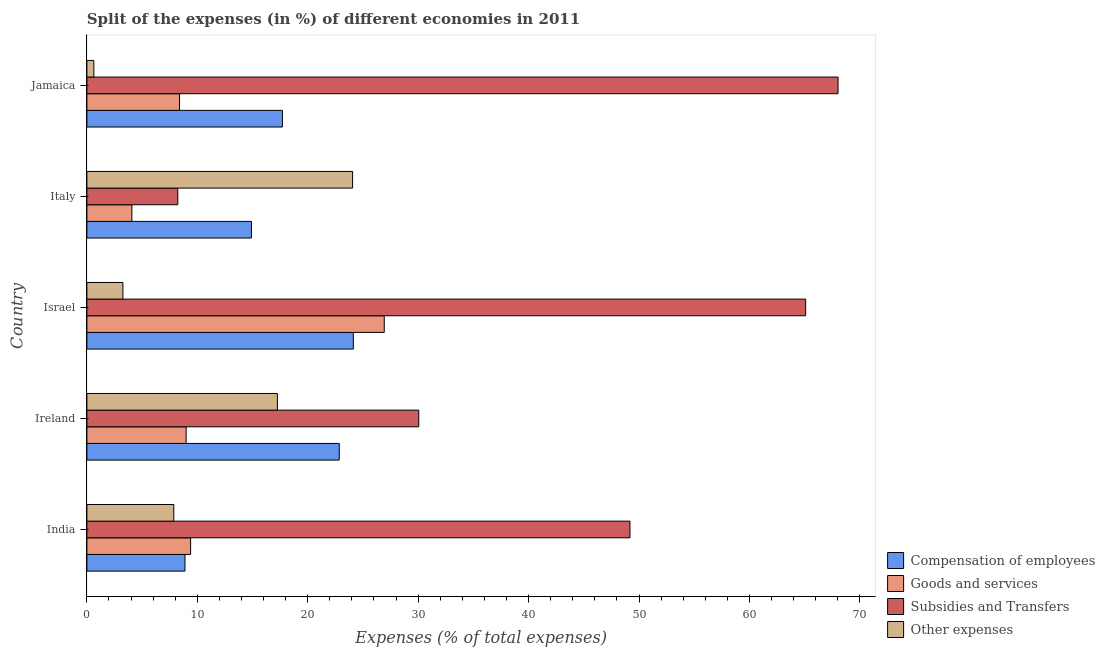How many different coloured bars are there?
Your answer should be compact. 4. How many groups of bars are there?
Offer a terse response. 5. How many bars are there on the 3rd tick from the top?
Offer a very short reply. 4. How many bars are there on the 1st tick from the bottom?
Ensure brevity in your answer.  4. What is the label of the 4th group of bars from the top?
Your answer should be very brief. Ireland. What is the percentage of amount spent on subsidies in Israel?
Keep it short and to the point. 65.09. Across all countries, what is the maximum percentage of amount spent on goods and services?
Your answer should be compact. 26.93. Across all countries, what is the minimum percentage of amount spent on other expenses?
Keep it short and to the point. 0.63. What is the total percentage of amount spent on goods and services in the graph?
Make the answer very short. 57.77. What is the difference between the percentage of amount spent on compensation of employees in Ireland and that in Italy?
Your response must be concise. 7.95. What is the difference between the percentage of amount spent on other expenses in Jamaica and the percentage of amount spent on goods and services in Italy?
Make the answer very short. -3.44. What is the average percentage of amount spent on goods and services per country?
Provide a short and direct response. 11.55. What is the difference between the percentage of amount spent on compensation of employees and percentage of amount spent on other expenses in Israel?
Provide a short and direct response. 20.87. What is the ratio of the percentage of amount spent on compensation of employees in Ireland to that in Israel?
Ensure brevity in your answer.  0.95. Is the percentage of amount spent on subsidies in Ireland less than that in Italy?
Your answer should be compact. No. Is the difference between the percentage of amount spent on compensation of employees in Ireland and Israel greater than the difference between the percentage of amount spent on other expenses in Ireland and Israel?
Give a very brief answer. No. What is the difference between the highest and the second highest percentage of amount spent on subsidies?
Provide a succinct answer. 2.94. What is the difference between the highest and the lowest percentage of amount spent on subsidies?
Your response must be concise. 59.79. Is it the case that in every country, the sum of the percentage of amount spent on goods and services and percentage of amount spent on compensation of employees is greater than the sum of percentage of amount spent on subsidies and percentage of amount spent on other expenses?
Offer a very short reply. No. What does the 3rd bar from the top in India represents?
Your answer should be compact. Goods and services. What does the 1st bar from the bottom in Israel represents?
Your response must be concise. Compensation of employees. Is it the case that in every country, the sum of the percentage of amount spent on compensation of employees and percentage of amount spent on goods and services is greater than the percentage of amount spent on subsidies?
Ensure brevity in your answer.  No. Are all the bars in the graph horizontal?
Keep it short and to the point. Yes. How many countries are there in the graph?
Ensure brevity in your answer.  5. Does the graph contain any zero values?
Keep it short and to the point. No. Does the graph contain grids?
Make the answer very short. No. Where does the legend appear in the graph?
Provide a short and direct response. Bottom right. How many legend labels are there?
Provide a short and direct response. 4. What is the title of the graph?
Your response must be concise. Split of the expenses (in %) of different economies in 2011. Does "Other expenses" appear as one of the legend labels in the graph?
Your answer should be very brief. Yes. What is the label or title of the X-axis?
Provide a short and direct response. Expenses (% of total expenses). What is the Expenses (% of total expenses) in Compensation of employees in India?
Provide a short and direct response. 8.88. What is the Expenses (% of total expenses) in Goods and services in India?
Provide a short and direct response. 9.39. What is the Expenses (% of total expenses) in Subsidies and Transfers in India?
Keep it short and to the point. 49.18. What is the Expenses (% of total expenses) of Other expenses in India?
Offer a terse response. 7.87. What is the Expenses (% of total expenses) in Compensation of employees in Ireland?
Give a very brief answer. 22.86. What is the Expenses (% of total expenses) of Goods and services in Ireland?
Provide a short and direct response. 8.99. What is the Expenses (% of total expenses) of Subsidies and Transfers in Ireland?
Provide a succinct answer. 30.06. What is the Expenses (% of total expenses) in Other expenses in Ireland?
Keep it short and to the point. 17.25. What is the Expenses (% of total expenses) of Compensation of employees in Israel?
Your answer should be compact. 24.13. What is the Expenses (% of total expenses) of Goods and services in Israel?
Your answer should be compact. 26.93. What is the Expenses (% of total expenses) of Subsidies and Transfers in Israel?
Give a very brief answer. 65.09. What is the Expenses (% of total expenses) in Other expenses in Israel?
Make the answer very short. 3.26. What is the Expenses (% of total expenses) in Compensation of employees in Italy?
Ensure brevity in your answer.  14.9. What is the Expenses (% of total expenses) of Goods and services in Italy?
Your answer should be compact. 4.07. What is the Expenses (% of total expenses) of Subsidies and Transfers in Italy?
Provide a succinct answer. 8.23. What is the Expenses (% of total expenses) in Other expenses in Italy?
Provide a short and direct response. 24.06. What is the Expenses (% of total expenses) of Compensation of employees in Jamaica?
Offer a terse response. 17.71. What is the Expenses (% of total expenses) in Goods and services in Jamaica?
Give a very brief answer. 8.39. What is the Expenses (% of total expenses) of Subsidies and Transfers in Jamaica?
Your answer should be compact. 68.03. What is the Expenses (% of total expenses) in Other expenses in Jamaica?
Provide a succinct answer. 0.63. Across all countries, what is the maximum Expenses (% of total expenses) in Compensation of employees?
Offer a terse response. 24.13. Across all countries, what is the maximum Expenses (% of total expenses) in Goods and services?
Make the answer very short. 26.93. Across all countries, what is the maximum Expenses (% of total expenses) in Subsidies and Transfers?
Keep it short and to the point. 68.03. Across all countries, what is the maximum Expenses (% of total expenses) of Other expenses?
Your response must be concise. 24.06. Across all countries, what is the minimum Expenses (% of total expenses) of Compensation of employees?
Your answer should be compact. 8.88. Across all countries, what is the minimum Expenses (% of total expenses) in Goods and services?
Your response must be concise. 4.07. Across all countries, what is the minimum Expenses (% of total expenses) of Subsidies and Transfers?
Your answer should be compact. 8.23. Across all countries, what is the minimum Expenses (% of total expenses) of Other expenses?
Offer a terse response. 0.63. What is the total Expenses (% of total expenses) in Compensation of employees in the graph?
Keep it short and to the point. 88.48. What is the total Expenses (% of total expenses) in Goods and services in the graph?
Provide a short and direct response. 57.77. What is the total Expenses (% of total expenses) of Subsidies and Transfers in the graph?
Ensure brevity in your answer.  220.59. What is the total Expenses (% of total expenses) in Other expenses in the graph?
Offer a terse response. 53.08. What is the difference between the Expenses (% of total expenses) of Compensation of employees in India and that in Ireland?
Keep it short and to the point. -13.97. What is the difference between the Expenses (% of total expenses) of Goods and services in India and that in Ireland?
Provide a short and direct response. 0.41. What is the difference between the Expenses (% of total expenses) of Subsidies and Transfers in India and that in Ireland?
Keep it short and to the point. 19.13. What is the difference between the Expenses (% of total expenses) in Other expenses in India and that in Ireland?
Your answer should be compact. -9.38. What is the difference between the Expenses (% of total expenses) in Compensation of employees in India and that in Israel?
Your response must be concise. -15.25. What is the difference between the Expenses (% of total expenses) in Goods and services in India and that in Israel?
Offer a terse response. -17.54. What is the difference between the Expenses (% of total expenses) of Subsidies and Transfers in India and that in Israel?
Make the answer very short. -15.91. What is the difference between the Expenses (% of total expenses) in Other expenses in India and that in Israel?
Give a very brief answer. 4.61. What is the difference between the Expenses (% of total expenses) in Compensation of employees in India and that in Italy?
Your answer should be very brief. -6.02. What is the difference between the Expenses (% of total expenses) of Goods and services in India and that in Italy?
Your response must be concise. 5.32. What is the difference between the Expenses (% of total expenses) of Subsidies and Transfers in India and that in Italy?
Make the answer very short. 40.95. What is the difference between the Expenses (% of total expenses) of Other expenses in India and that in Italy?
Your answer should be compact. -16.19. What is the difference between the Expenses (% of total expenses) of Compensation of employees in India and that in Jamaica?
Make the answer very short. -8.83. What is the difference between the Expenses (% of total expenses) of Subsidies and Transfers in India and that in Jamaica?
Give a very brief answer. -18.84. What is the difference between the Expenses (% of total expenses) in Other expenses in India and that in Jamaica?
Give a very brief answer. 7.24. What is the difference between the Expenses (% of total expenses) in Compensation of employees in Ireland and that in Israel?
Your answer should be compact. -1.28. What is the difference between the Expenses (% of total expenses) in Goods and services in Ireland and that in Israel?
Provide a succinct answer. -17.94. What is the difference between the Expenses (% of total expenses) in Subsidies and Transfers in Ireland and that in Israel?
Provide a succinct answer. -35.03. What is the difference between the Expenses (% of total expenses) of Other expenses in Ireland and that in Israel?
Give a very brief answer. 13.99. What is the difference between the Expenses (% of total expenses) of Compensation of employees in Ireland and that in Italy?
Make the answer very short. 7.95. What is the difference between the Expenses (% of total expenses) in Goods and services in Ireland and that in Italy?
Your response must be concise. 4.91. What is the difference between the Expenses (% of total expenses) of Subsidies and Transfers in Ireland and that in Italy?
Provide a short and direct response. 21.82. What is the difference between the Expenses (% of total expenses) of Other expenses in Ireland and that in Italy?
Ensure brevity in your answer.  -6.81. What is the difference between the Expenses (% of total expenses) of Compensation of employees in Ireland and that in Jamaica?
Make the answer very short. 5.15. What is the difference between the Expenses (% of total expenses) in Goods and services in Ireland and that in Jamaica?
Ensure brevity in your answer.  0.6. What is the difference between the Expenses (% of total expenses) of Subsidies and Transfers in Ireland and that in Jamaica?
Provide a short and direct response. -37.97. What is the difference between the Expenses (% of total expenses) of Other expenses in Ireland and that in Jamaica?
Give a very brief answer. 16.62. What is the difference between the Expenses (% of total expenses) in Compensation of employees in Israel and that in Italy?
Give a very brief answer. 9.23. What is the difference between the Expenses (% of total expenses) in Goods and services in Israel and that in Italy?
Make the answer very short. 22.86. What is the difference between the Expenses (% of total expenses) of Subsidies and Transfers in Israel and that in Italy?
Give a very brief answer. 56.86. What is the difference between the Expenses (% of total expenses) of Other expenses in Israel and that in Italy?
Provide a short and direct response. -20.8. What is the difference between the Expenses (% of total expenses) in Compensation of employees in Israel and that in Jamaica?
Make the answer very short. 6.42. What is the difference between the Expenses (% of total expenses) in Goods and services in Israel and that in Jamaica?
Keep it short and to the point. 18.54. What is the difference between the Expenses (% of total expenses) of Subsidies and Transfers in Israel and that in Jamaica?
Give a very brief answer. -2.94. What is the difference between the Expenses (% of total expenses) of Other expenses in Israel and that in Jamaica?
Your answer should be compact. 2.63. What is the difference between the Expenses (% of total expenses) in Compensation of employees in Italy and that in Jamaica?
Provide a succinct answer. -2.8. What is the difference between the Expenses (% of total expenses) in Goods and services in Italy and that in Jamaica?
Ensure brevity in your answer.  -4.32. What is the difference between the Expenses (% of total expenses) in Subsidies and Transfers in Italy and that in Jamaica?
Offer a terse response. -59.79. What is the difference between the Expenses (% of total expenses) of Other expenses in Italy and that in Jamaica?
Give a very brief answer. 23.43. What is the difference between the Expenses (% of total expenses) of Compensation of employees in India and the Expenses (% of total expenses) of Goods and services in Ireland?
Your answer should be very brief. -0.11. What is the difference between the Expenses (% of total expenses) in Compensation of employees in India and the Expenses (% of total expenses) in Subsidies and Transfers in Ireland?
Ensure brevity in your answer.  -21.17. What is the difference between the Expenses (% of total expenses) in Compensation of employees in India and the Expenses (% of total expenses) in Other expenses in Ireland?
Offer a very short reply. -8.37. What is the difference between the Expenses (% of total expenses) in Goods and services in India and the Expenses (% of total expenses) in Subsidies and Transfers in Ireland?
Your response must be concise. -20.66. What is the difference between the Expenses (% of total expenses) of Goods and services in India and the Expenses (% of total expenses) of Other expenses in Ireland?
Make the answer very short. -7.86. What is the difference between the Expenses (% of total expenses) in Subsidies and Transfers in India and the Expenses (% of total expenses) in Other expenses in Ireland?
Provide a short and direct response. 31.93. What is the difference between the Expenses (% of total expenses) in Compensation of employees in India and the Expenses (% of total expenses) in Goods and services in Israel?
Provide a short and direct response. -18.05. What is the difference between the Expenses (% of total expenses) in Compensation of employees in India and the Expenses (% of total expenses) in Subsidies and Transfers in Israel?
Offer a very short reply. -56.21. What is the difference between the Expenses (% of total expenses) in Compensation of employees in India and the Expenses (% of total expenses) in Other expenses in Israel?
Give a very brief answer. 5.62. What is the difference between the Expenses (% of total expenses) of Goods and services in India and the Expenses (% of total expenses) of Subsidies and Transfers in Israel?
Provide a succinct answer. -55.7. What is the difference between the Expenses (% of total expenses) in Goods and services in India and the Expenses (% of total expenses) in Other expenses in Israel?
Make the answer very short. 6.13. What is the difference between the Expenses (% of total expenses) of Subsidies and Transfers in India and the Expenses (% of total expenses) of Other expenses in Israel?
Offer a very short reply. 45.92. What is the difference between the Expenses (% of total expenses) in Compensation of employees in India and the Expenses (% of total expenses) in Goods and services in Italy?
Your response must be concise. 4.81. What is the difference between the Expenses (% of total expenses) of Compensation of employees in India and the Expenses (% of total expenses) of Subsidies and Transfers in Italy?
Keep it short and to the point. 0.65. What is the difference between the Expenses (% of total expenses) in Compensation of employees in India and the Expenses (% of total expenses) in Other expenses in Italy?
Offer a terse response. -15.18. What is the difference between the Expenses (% of total expenses) of Goods and services in India and the Expenses (% of total expenses) of Subsidies and Transfers in Italy?
Make the answer very short. 1.16. What is the difference between the Expenses (% of total expenses) in Goods and services in India and the Expenses (% of total expenses) in Other expenses in Italy?
Provide a succinct answer. -14.67. What is the difference between the Expenses (% of total expenses) of Subsidies and Transfers in India and the Expenses (% of total expenses) of Other expenses in Italy?
Keep it short and to the point. 25.12. What is the difference between the Expenses (% of total expenses) of Compensation of employees in India and the Expenses (% of total expenses) of Goods and services in Jamaica?
Offer a terse response. 0.49. What is the difference between the Expenses (% of total expenses) in Compensation of employees in India and the Expenses (% of total expenses) in Subsidies and Transfers in Jamaica?
Your answer should be compact. -59.15. What is the difference between the Expenses (% of total expenses) of Compensation of employees in India and the Expenses (% of total expenses) of Other expenses in Jamaica?
Ensure brevity in your answer.  8.25. What is the difference between the Expenses (% of total expenses) in Goods and services in India and the Expenses (% of total expenses) in Subsidies and Transfers in Jamaica?
Keep it short and to the point. -58.63. What is the difference between the Expenses (% of total expenses) in Goods and services in India and the Expenses (% of total expenses) in Other expenses in Jamaica?
Ensure brevity in your answer.  8.76. What is the difference between the Expenses (% of total expenses) of Subsidies and Transfers in India and the Expenses (% of total expenses) of Other expenses in Jamaica?
Give a very brief answer. 48.55. What is the difference between the Expenses (% of total expenses) of Compensation of employees in Ireland and the Expenses (% of total expenses) of Goods and services in Israel?
Give a very brief answer. -4.07. What is the difference between the Expenses (% of total expenses) in Compensation of employees in Ireland and the Expenses (% of total expenses) in Subsidies and Transfers in Israel?
Provide a succinct answer. -42.23. What is the difference between the Expenses (% of total expenses) of Compensation of employees in Ireland and the Expenses (% of total expenses) of Other expenses in Israel?
Ensure brevity in your answer.  19.59. What is the difference between the Expenses (% of total expenses) in Goods and services in Ireland and the Expenses (% of total expenses) in Subsidies and Transfers in Israel?
Offer a very short reply. -56.1. What is the difference between the Expenses (% of total expenses) of Goods and services in Ireland and the Expenses (% of total expenses) of Other expenses in Israel?
Your answer should be compact. 5.73. What is the difference between the Expenses (% of total expenses) in Subsidies and Transfers in Ireland and the Expenses (% of total expenses) in Other expenses in Israel?
Offer a terse response. 26.79. What is the difference between the Expenses (% of total expenses) of Compensation of employees in Ireland and the Expenses (% of total expenses) of Goods and services in Italy?
Offer a very short reply. 18.78. What is the difference between the Expenses (% of total expenses) in Compensation of employees in Ireland and the Expenses (% of total expenses) in Subsidies and Transfers in Italy?
Offer a very short reply. 14.62. What is the difference between the Expenses (% of total expenses) of Compensation of employees in Ireland and the Expenses (% of total expenses) of Other expenses in Italy?
Provide a short and direct response. -1.21. What is the difference between the Expenses (% of total expenses) in Goods and services in Ireland and the Expenses (% of total expenses) in Subsidies and Transfers in Italy?
Your answer should be compact. 0.75. What is the difference between the Expenses (% of total expenses) of Goods and services in Ireland and the Expenses (% of total expenses) of Other expenses in Italy?
Offer a terse response. -15.08. What is the difference between the Expenses (% of total expenses) of Subsidies and Transfers in Ireland and the Expenses (% of total expenses) of Other expenses in Italy?
Make the answer very short. 5.99. What is the difference between the Expenses (% of total expenses) in Compensation of employees in Ireland and the Expenses (% of total expenses) in Goods and services in Jamaica?
Ensure brevity in your answer.  14.47. What is the difference between the Expenses (% of total expenses) of Compensation of employees in Ireland and the Expenses (% of total expenses) of Subsidies and Transfers in Jamaica?
Offer a very short reply. -45.17. What is the difference between the Expenses (% of total expenses) of Compensation of employees in Ireland and the Expenses (% of total expenses) of Other expenses in Jamaica?
Offer a very short reply. 22.22. What is the difference between the Expenses (% of total expenses) of Goods and services in Ireland and the Expenses (% of total expenses) of Subsidies and Transfers in Jamaica?
Your answer should be compact. -59.04. What is the difference between the Expenses (% of total expenses) in Goods and services in Ireland and the Expenses (% of total expenses) in Other expenses in Jamaica?
Make the answer very short. 8.35. What is the difference between the Expenses (% of total expenses) of Subsidies and Transfers in Ireland and the Expenses (% of total expenses) of Other expenses in Jamaica?
Offer a very short reply. 29.42. What is the difference between the Expenses (% of total expenses) of Compensation of employees in Israel and the Expenses (% of total expenses) of Goods and services in Italy?
Give a very brief answer. 20.06. What is the difference between the Expenses (% of total expenses) of Compensation of employees in Israel and the Expenses (% of total expenses) of Subsidies and Transfers in Italy?
Offer a terse response. 15.9. What is the difference between the Expenses (% of total expenses) of Compensation of employees in Israel and the Expenses (% of total expenses) of Other expenses in Italy?
Your answer should be compact. 0.07. What is the difference between the Expenses (% of total expenses) of Goods and services in Israel and the Expenses (% of total expenses) of Subsidies and Transfers in Italy?
Give a very brief answer. 18.7. What is the difference between the Expenses (% of total expenses) in Goods and services in Israel and the Expenses (% of total expenses) in Other expenses in Italy?
Give a very brief answer. 2.87. What is the difference between the Expenses (% of total expenses) of Subsidies and Transfers in Israel and the Expenses (% of total expenses) of Other expenses in Italy?
Keep it short and to the point. 41.03. What is the difference between the Expenses (% of total expenses) in Compensation of employees in Israel and the Expenses (% of total expenses) in Goods and services in Jamaica?
Ensure brevity in your answer.  15.74. What is the difference between the Expenses (% of total expenses) of Compensation of employees in Israel and the Expenses (% of total expenses) of Subsidies and Transfers in Jamaica?
Your answer should be compact. -43.9. What is the difference between the Expenses (% of total expenses) in Compensation of employees in Israel and the Expenses (% of total expenses) in Other expenses in Jamaica?
Your answer should be very brief. 23.5. What is the difference between the Expenses (% of total expenses) of Goods and services in Israel and the Expenses (% of total expenses) of Subsidies and Transfers in Jamaica?
Your answer should be compact. -41.1. What is the difference between the Expenses (% of total expenses) of Goods and services in Israel and the Expenses (% of total expenses) of Other expenses in Jamaica?
Keep it short and to the point. 26.3. What is the difference between the Expenses (% of total expenses) in Subsidies and Transfers in Israel and the Expenses (% of total expenses) in Other expenses in Jamaica?
Your answer should be compact. 64.46. What is the difference between the Expenses (% of total expenses) of Compensation of employees in Italy and the Expenses (% of total expenses) of Goods and services in Jamaica?
Keep it short and to the point. 6.52. What is the difference between the Expenses (% of total expenses) of Compensation of employees in Italy and the Expenses (% of total expenses) of Subsidies and Transfers in Jamaica?
Make the answer very short. -53.12. What is the difference between the Expenses (% of total expenses) of Compensation of employees in Italy and the Expenses (% of total expenses) of Other expenses in Jamaica?
Keep it short and to the point. 14.27. What is the difference between the Expenses (% of total expenses) in Goods and services in Italy and the Expenses (% of total expenses) in Subsidies and Transfers in Jamaica?
Give a very brief answer. -63.95. What is the difference between the Expenses (% of total expenses) of Goods and services in Italy and the Expenses (% of total expenses) of Other expenses in Jamaica?
Ensure brevity in your answer.  3.44. What is the difference between the Expenses (% of total expenses) of Subsidies and Transfers in Italy and the Expenses (% of total expenses) of Other expenses in Jamaica?
Offer a very short reply. 7.6. What is the average Expenses (% of total expenses) in Compensation of employees per country?
Give a very brief answer. 17.7. What is the average Expenses (% of total expenses) of Goods and services per country?
Your answer should be compact. 11.55. What is the average Expenses (% of total expenses) in Subsidies and Transfers per country?
Provide a succinct answer. 44.12. What is the average Expenses (% of total expenses) in Other expenses per country?
Keep it short and to the point. 10.62. What is the difference between the Expenses (% of total expenses) in Compensation of employees and Expenses (% of total expenses) in Goods and services in India?
Your answer should be compact. -0.51. What is the difference between the Expenses (% of total expenses) of Compensation of employees and Expenses (% of total expenses) of Subsidies and Transfers in India?
Your response must be concise. -40.3. What is the difference between the Expenses (% of total expenses) in Compensation of employees and Expenses (% of total expenses) in Other expenses in India?
Offer a terse response. 1.01. What is the difference between the Expenses (% of total expenses) of Goods and services and Expenses (% of total expenses) of Subsidies and Transfers in India?
Offer a terse response. -39.79. What is the difference between the Expenses (% of total expenses) of Goods and services and Expenses (% of total expenses) of Other expenses in India?
Offer a very short reply. 1.52. What is the difference between the Expenses (% of total expenses) in Subsidies and Transfers and Expenses (% of total expenses) in Other expenses in India?
Keep it short and to the point. 41.31. What is the difference between the Expenses (% of total expenses) in Compensation of employees and Expenses (% of total expenses) in Goods and services in Ireland?
Offer a terse response. 13.87. What is the difference between the Expenses (% of total expenses) in Compensation of employees and Expenses (% of total expenses) in Subsidies and Transfers in Ireland?
Provide a short and direct response. -7.2. What is the difference between the Expenses (% of total expenses) of Compensation of employees and Expenses (% of total expenses) of Other expenses in Ireland?
Give a very brief answer. 5.6. What is the difference between the Expenses (% of total expenses) in Goods and services and Expenses (% of total expenses) in Subsidies and Transfers in Ireland?
Provide a short and direct response. -21.07. What is the difference between the Expenses (% of total expenses) in Goods and services and Expenses (% of total expenses) in Other expenses in Ireland?
Ensure brevity in your answer.  -8.27. What is the difference between the Expenses (% of total expenses) in Subsidies and Transfers and Expenses (% of total expenses) in Other expenses in Ireland?
Keep it short and to the point. 12.8. What is the difference between the Expenses (% of total expenses) of Compensation of employees and Expenses (% of total expenses) of Goods and services in Israel?
Your answer should be compact. -2.8. What is the difference between the Expenses (% of total expenses) of Compensation of employees and Expenses (% of total expenses) of Subsidies and Transfers in Israel?
Provide a short and direct response. -40.96. What is the difference between the Expenses (% of total expenses) in Compensation of employees and Expenses (% of total expenses) in Other expenses in Israel?
Provide a short and direct response. 20.87. What is the difference between the Expenses (% of total expenses) of Goods and services and Expenses (% of total expenses) of Subsidies and Transfers in Israel?
Provide a succinct answer. -38.16. What is the difference between the Expenses (% of total expenses) in Goods and services and Expenses (% of total expenses) in Other expenses in Israel?
Offer a terse response. 23.67. What is the difference between the Expenses (% of total expenses) of Subsidies and Transfers and Expenses (% of total expenses) of Other expenses in Israel?
Ensure brevity in your answer.  61.83. What is the difference between the Expenses (% of total expenses) in Compensation of employees and Expenses (% of total expenses) in Goods and services in Italy?
Make the answer very short. 10.83. What is the difference between the Expenses (% of total expenses) in Compensation of employees and Expenses (% of total expenses) in Subsidies and Transfers in Italy?
Give a very brief answer. 6.67. What is the difference between the Expenses (% of total expenses) of Compensation of employees and Expenses (% of total expenses) of Other expenses in Italy?
Offer a terse response. -9.16. What is the difference between the Expenses (% of total expenses) of Goods and services and Expenses (% of total expenses) of Subsidies and Transfers in Italy?
Keep it short and to the point. -4.16. What is the difference between the Expenses (% of total expenses) of Goods and services and Expenses (% of total expenses) of Other expenses in Italy?
Keep it short and to the point. -19.99. What is the difference between the Expenses (% of total expenses) of Subsidies and Transfers and Expenses (% of total expenses) of Other expenses in Italy?
Ensure brevity in your answer.  -15.83. What is the difference between the Expenses (% of total expenses) of Compensation of employees and Expenses (% of total expenses) of Goods and services in Jamaica?
Your answer should be compact. 9.32. What is the difference between the Expenses (% of total expenses) in Compensation of employees and Expenses (% of total expenses) in Subsidies and Transfers in Jamaica?
Your answer should be compact. -50.32. What is the difference between the Expenses (% of total expenses) in Compensation of employees and Expenses (% of total expenses) in Other expenses in Jamaica?
Make the answer very short. 17.07. What is the difference between the Expenses (% of total expenses) in Goods and services and Expenses (% of total expenses) in Subsidies and Transfers in Jamaica?
Offer a very short reply. -59.64. What is the difference between the Expenses (% of total expenses) of Goods and services and Expenses (% of total expenses) of Other expenses in Jamaica?
Offer a terse response. 7.76. What is the difference between the Expenses (% of total expenses) in Subsidies and Transfers and Expenses (% of total expenses) in Other expenses in Jamaica?
Your answer should be compact. 67.39. What is the ratio of the Expenses (% of total expenses) in Compensation of employees in India to that in Ireland?
Give a very brief answer. 0.39. What is the ratio of the Expenses (% of total expenses) of Goods and services in India to that in Ireland?
Provide a succinct answer. 1.05. What is the ratio of the Expenses (% of total expenses) in Subsidies and Transfers in India to that in Ireland?
Offer a very short reply. 1.64. What is the ratio of the Expenses (% of total expenses) in Other expenses in India to that in Ireland?
Your response must be concise. 0.46. What is the ratio of the Expenses (% of total expenses) in Compensation of employees in India to that in Israel?
Keep it short and to the point. 0.37. What is the ratio of the Expenses (% of total expenses) in Goods and services in India to that in Israel?
Provide a short and direct response. 0.35. What is the ratio of the Expenses (% of total expenses) in Subsidies and Transfers in India to that in Israel?
Give a very brief answer. 0.76. What is the ratio of the Expenses (% of total expenses) in Other expenses in India to that in Israel?
Offer a terse response. 2.41. What is the ratio of the Expenses (% of total expenses) in Compensation of employees in India to that in Italy?
Provide a succinct answer. 0.6. What is the ratio of the Expenses (% of total expenses) in Goods and services in India to that in Italy?
Your response must be concise. 2.31. What is the ratio of the Expenses (% of total expenses) of Subsidies and Transfers in India to that in Italy?
Your response must be concise. 5.97. What is the ratio of the Expenses (% of total expenses) of Other expenses in India to that in Italy?
Provide a short and direct response. 0.33. What is the ratio of the Expenses (% of total expenses) of Compensation of employees in India to that in Jamaica?
Your answer should be compact. 0.5. What is the ratio of the Expenses (% of total expenses) in Goods and services in India to that in Jamaica?
Ensure brevity in your answer.  1.12. What is the ratio of the Expenses (% of total expenses) of Subsidies and Transfers in India to that in Jamaica?
Your answer should be compact. 0.72. What is the ratio of the Expenses (% of total expenses) in Other expenses in India to that in Jamaica?
Offer a very short reply. 12.44. What is the ratio of the Expenses (% of total expenses) of Compensation of employees in Ireland to that in Israel?
Offer a terse response. 0.95. What is the ratio of the Expenses (% of total expenses) of Goods and services in Ireland to that in Israel?
Offer a very short reply. 0.33. What is the ratio of the Expenses (% of total expenses) of Subsidies and Transfers in Ireland to that in Israel?
Your answer should be compact. 0.46. What is the ratio of the Expenses (% of total expenses) in Other expenses in Ireland to that in Israel?
Offer a terse response. 5.29. What is the ratio of the Expenses (% of total expenses) in Compensation of employees in Ireland to that in Italy?
Your response must be concise. 1.53. What is the ratio of the Expenses (% of total expenses) in Goods and services in Ireland to that in Italy?
Give a very brief answer. 2.21. What is the ratio of the Expenses (% of total expenses) of Subsidies and Transfers in Ireland to that in Italy?
Offer a terse response. 3.65. What is the ratio of the Expenses (% of total expenses) in Other expenses in Ireland to that in Italy?
Make the answer very short. 0.72. What is the ratio of the Expenses (% of total expenses) of Compensation of employees in Ireland to that in Jamaica?
Give a very brief answer. 1.29. What is the ratio of the Expenses (% of total expenses) in Goods and services in Ireland to that in Jamaica?
Give a very brief answer. 1.07. What is the ratio of the Expenses (% of total expenses) in Subsidies and Transfers in Ireland to that in Jamaica?
Your answer should be compact. 0.44. What is the ratio of the Expenses (% of total expenses) of Other expenses in Ireland to that in Jamaica?
Provide a short and direct response. 27.28. What is the ratio of the Expenses (% of total expenses) of Compensation of employees in Israel to that in Italy?
Your answer should be very brief. 1.62. What is the ratio of the Expenses (% of total expenses) in Goods and services in Israel to that in Italy?
Provide a succinct answer. 6.61. What is the ratio of the Expenses (% of total expenses) in Subsidies and Transfers in Israel to that in Italy?
Your answer should be very brief. 7.91. What is the ratio of the Expenses (% of total expenses) in Other expenses in Israel to that in Italy?
Offer a terse response. 0.14. What is the ratio of the Expenses (% of total expenses) in Compensation of employees in Israel to that in Jamaica?
Provide a short and direct response. 1.36. What is the ratio of the Expenses (% of total expenses) in Goods and services in Israel to that in Jamaica?
Keep it short and to the point. 3.21. What is the ratio of the Expenses (% of total expenses) of Subsidies and Transfers in Israel to that in Jamaica?
Offer a terse response. 0.96. What is the ratio of the Expenses (% of total expenses) in Other expenses in Israel to that in Jamaica?
Provide a succinct answer. 5.16. What is the ratio of the Expenses (% of total expenses) in Compensation of employees in Italy to that in Jamaica?
Ensure brevity in your answer.  0.84. What is the ratio of the Expenses (% of total expenses) in Goods and services in Italy to that in Jamaica?
Keep it short and to the point. 0.49. What is the ratio of the Expenses (% of total expenses) in Subsidies and Transfers in Italy to that in Jamaica?
Your answer should be compact. 0.12. What is the ratio of the Expenses (% of total expenses) of Other expenses in Italy to that in Jamaica?
Provide a short and direct response. 38.05. What is the difference between the highest and the second highest Expenses (% of total expenses) in Compensation of employees?
Offer a very short reply. 1.28. What is the difference between the highest and the second highest Expenses (% of total expenses) in Goods and services?
Provide a succinct answer. 17.54. What is the difference between the highest and the second highest Expenses (% of total expenses) in Subsidies and Transfers?
Make the answer very short. 2.94. What is the difference between the highest and the second highest Expenses (% of total expenses) of Other expenses?
Ensure brevity in your answer.  6.81. What is the difference between the highest and the lowest Expenses (% of total expenses) of Compensation of employees?
Ensure brevity in your answer.  15.25. What is the difference between the highest and the lowest Expenses (% of total expenses) in Goods and services?
Your response must be concise. 22.86. What is the difference between the highest and the lowest Expenses (% of total expenses) in Subsidies and Transfers?
Give a very brief answer. 59.79. What is the difference between the highest and the lowest Expenses (% of total expenses) in Other expenses?
Make the answer very short. 23.43. 